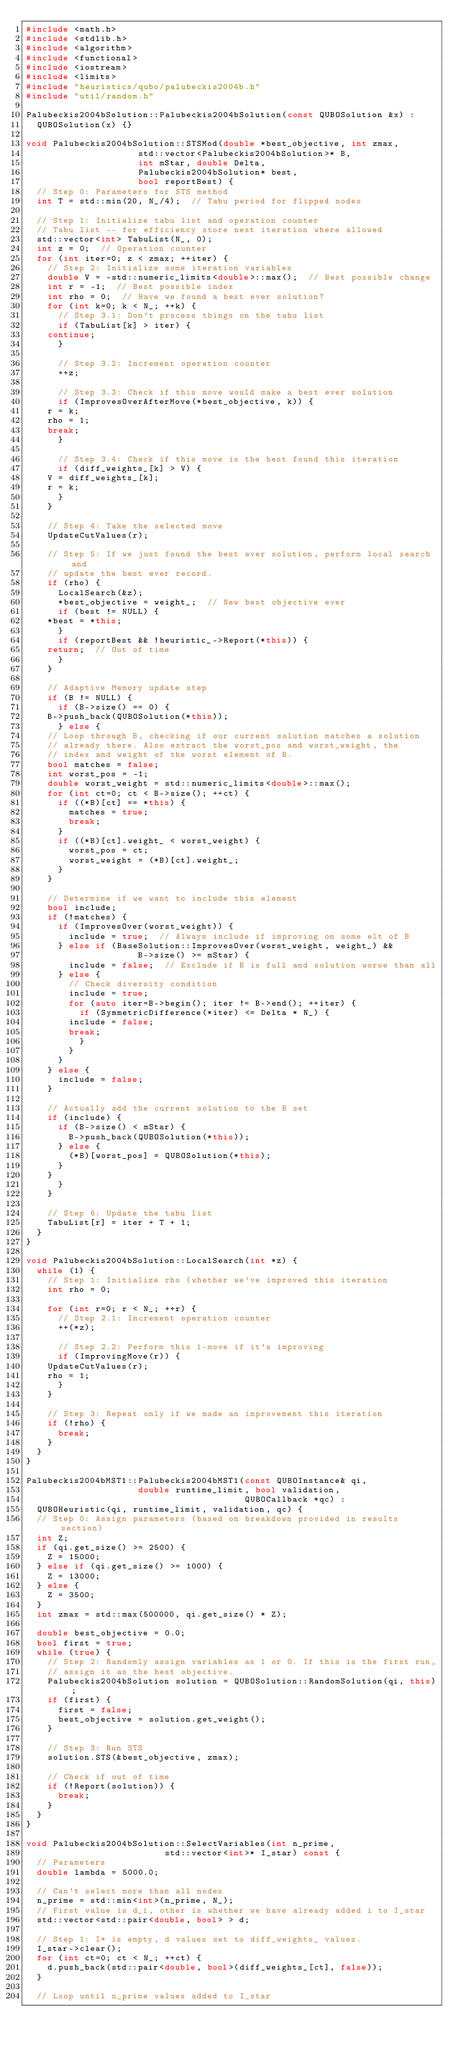Convert code to text. <code><loc_0><loc_0><loc_500><loc_500><_C++_>#include <math.h>
#include <stdlib.h>
#include <algorithm>
#include <functional>
#include <iostream>
#include <limits>
#include "heuristics/qubo/palubeckis2004b.h"
#include "util/random.h"

Palubeckis2004bSolution::Palubeckis2004bSolution(const QUBOSolution &x) :
  QUBOSolution(x) {}

void Palubeckis2004bSolution::STSMod(double *best_objective, int zmax,
				     std::vector<Palubeckis2004bSolution>* B,
				     int mStar, double Delta,
				     Palubeckis2004bSolution* best,
				     bool reportBest) {
  // Step 0: Parameters for STS method
  int T = std::min(20, N_/4);  // Tabu period for flipped nodes

  // Step 1: Initialize tabu list and operation counter
  // Tabu list -- for efficiency store next iteration where allowed
  std::vector<int> TabuList(N_, 0);
  int z = 0;  // Operation counter
  for (int iter=0; z < zmax; ++iter) {
    // Step 2: Initialize some iteration variables
    double V = -std::numeric_limits<double>::max();  // Best possible change
    int r = -1;  // Best possible index
    int rho = 0;  // Have we found a best ever solution?
    for (int k=0; k < N_; ++k) {
      // Step 3.1: Don't process things on the tabu list
      if (TabuList[k] > iter) {
	continue;
      }

      // Step 3.2: Increment operation counter
      ++z;

      // Step 3.3: Check if this move would make a best ever solution
      if (ImprovesOverAfterMove(*best_objective, k)) {
	r = k;
	rho = 1;
	break;
      }

      // Step 3.4: Check if this move is the best found this iteration
      if (diff_weights_[k] > V) {
	V = diff_weights_[k];
	r = k;
      }
    }

    // Step 4: Take the selected move
    UpdateCutValues(r);

    // Step 5: If we just found the best ever solution, perform local search and
    // update the best ever record.
    if (rho) {
      LocalSearch(&z);
      *best_objective = weight_;  // New best objective ever
      if (best != NULL) {
	*best = *this;
      }
      if (reportBest && !heuristic_->Report(*this)) {
	return;  // Out of time
      }
    }

    // Adaptive Memory update step
    if (B != NULL) {
      if (B->size() == 0) {
	B->push_back(QUBOSolution(*this));
      } else {
	// Loop through B, checking if our current solution matches a solution
	// already there. Also extract the worst_pos and worst_weight, the
	// index and weight of the worst element of B.
	bool matches = false;
	int worst_pos = -1;
	double worst_weight = std::numeric_limits<double>::max();
	for (int ct=0; ct < B->size(); ++ct) {
	  if ((*B)[ct] == *this) {
	    matches = true;
	    break;
	  }
	  if ((*B)[ct].weight_ < worst_weight) {
	    worst_pos = ct;
	    worst_weight = (*B)[ct].weight_;
	  }
	}

	// Determine if we want to include this element
	bool include;
	if (!matches) {
	  if (ImprovesOver(worst_weight)) {
	    include = true;  // Always include if improving on some elt of B
	  } else if (BaseSolution::ImprovesOver(worst_weight, weight_) &&
                     B->size() >= mStar) {
	    include = false;  // Exclude if B is full and solution worse than all
	  } else {
	    // Check diversity condition
	    include = true;
	    for (auto iter=B->begin(); iter != B->end(); ++iter) {
	      if (SymmetricDifference(*iter) <= Delta * N_) {
		include = false;
		break;
	      }
	    }
	  }
	} else {
	  include = false;
	}

	// Actually add the current solution to the B set
	if (include) {
	  if (B->size() < mStar) {
	    B->push_back(QUBOSolution(*this));
	  } else {
	    (*B)[worst_pos] = QUBOSolution(*this);
	  }
	}
      }
    }

    // Step 6: Update the tabu list
    TabuList[r] = iter + T + 1;
  }
}

void Palubeckis2004bSolution::LocalSearch(int *z) {
  while (1) {
    // Step 1: Initialize rho (whether we've improved this iteration
    int rho = 0;

    for (int r=0; r < N_; ++r) {
      // Step 2.1: Increment operation counter
      ++(*z);

      // Step 2.2: Perform this 1-move if it's improving
      if (ImprovingMove(r)) {
	UpdateCutValues(r);
	rho = 1;
      }
    }

    // Step 3: Repeat only if we made an improvement this iteration
    if (!rho) {
      break;
    }
  }
}

Palubeckis2004bMST1::Palubeckis2004bMST1(const QUBOInstance& qi,
					 double runtime_limit, bool validation,
                                         QUBOCallback *qc) :
  QUBOHeuristic(qi, runtime_limit, validation, qc) {
  // Step 0: Assign parameters (based on breakdown provided in results section)
  int Z;
  if (qi.get_size() >= 2500) {
    Z = 15000;
  } else if (qi.get_size() >= 1000) {
    Z = 13000;
  } else {
    Z = 3500;
  }
  int zmax = std::max(500000, qi.get_size() * Z);
  
  double best_objective = 0.0;
  bool first = true;
  while (true) {
    // Step 2: Randomly assign variables as 1 or 0. If this is the first run,
    // assign it as the best objective.
    Palubeckis2004bSolution solution = QUBOSolution::RandomSolution(qi, this);
    if (first) {
      first = false;
      best_objective = solution.get_weight();
    }
    
    // Step 3: Run STS
    solution.STS(&best_objective, zmax);
    
    // Check if out of time
    if (!Report(solution)) {
      break;
    }
  }
}

void Palubeckis2004bSolution::SelectVariables(int n_prime,
					      std::vector<int>* I_star) const {
  // Parameters
  double lambda = 5000.0;

  // Can't select more than all nodes
  n_prime = std::min<int>(n_prime, N_);
  // First value is d_i, other is whether we have already added i to I_star
  std::vector<std::pair<double, bool> > d;

  // Step 1: I* is empty, d values set to diff_weights_ values.
  I_star->clear();
  for (int ct=0; ct < N_; ++ct) {
    d.push_back(std::pair<double, bool>(diff_weights_[ct], false));
  }

  // Loop until n_prime values added to I_star</code> 